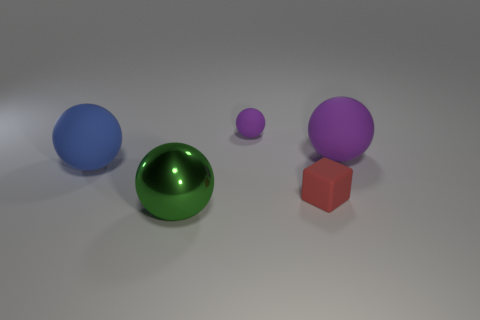Is there anything else that is the same material as the large green sphere?
Your response must be concise. No. How many other rubber cubes are the same color as the block?
Provide a succinct answer. 0. The purple thing that is the same size as the block is what shape?
Provide a short and direct response. Sphere. Are there any blue rubber balls left of the green object?
Provide a succinct answer. Yes. Do the green metallic sphere and the blue matte sphere have the same size?
Your answer should be very brief. Yes. What is the shape of the purple thing in front of the small matte ball?
Provide a short and direct response. Sphere. Is there a metal thing that has the same size as the blue ball?
Provide a short and direct response. Yes. What material is the green object that is the same size as the blue sphere?
Make the answer very short. Metal. What size is the purple thing that is left of the tiny block?
Keep it short and to the point. Small. The red thing is what size?
Your answer should be very brief. Small. 